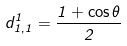<formula> <loc_0><loc_0><loc_500><loc_500>d _ { 1 , 1 } ^ { 1 } = \frac { 1 + \cos \theta } { 2 }</formula> 